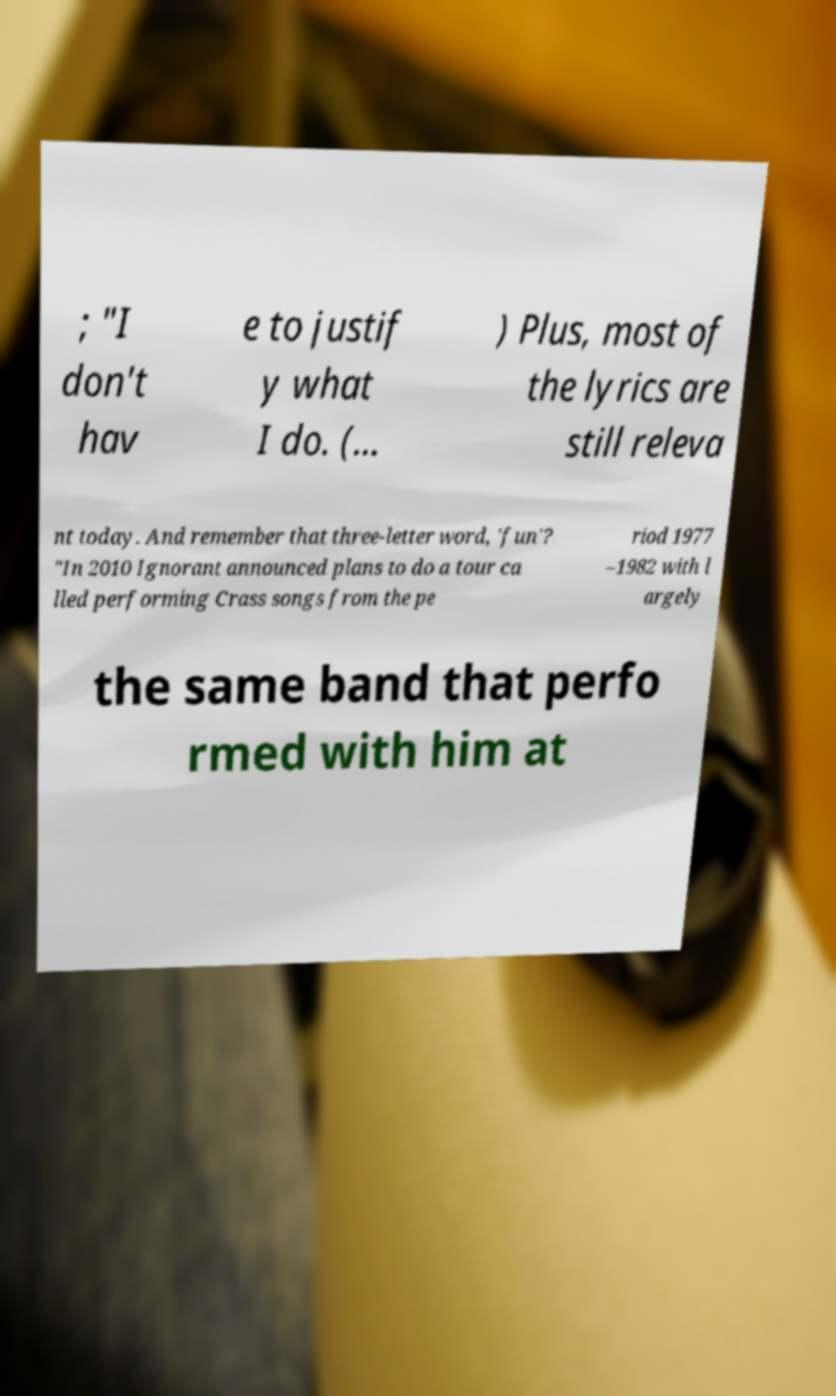I need the written content from this picture converted into text. Can you do that? ; "I don't hav e to justif y what I do. (... ) Plus, most of the lyrics are still releva nt today. And remember that three-letter word, 'fun'? "In 2010 Ignorant announced plans to do a tour ca lled performing Crass songs from the pe riod 1977 –1982 with l argely the same band that perfo rmed with him at 